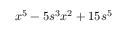<formula> <loc_0><loc_0><loc_500><loc_500>x ^ { 5 } - 5 s ^ { 3 } x ^ { 2 } + 1 5 s ^ { 5 }</formula> 